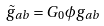Convert formula to latex. <formula><loc_0><loc_0><loc_500><loc_500>\tilde { g } _ { a b } = G _ { 0 } \phi g _ { a b }</formula> 